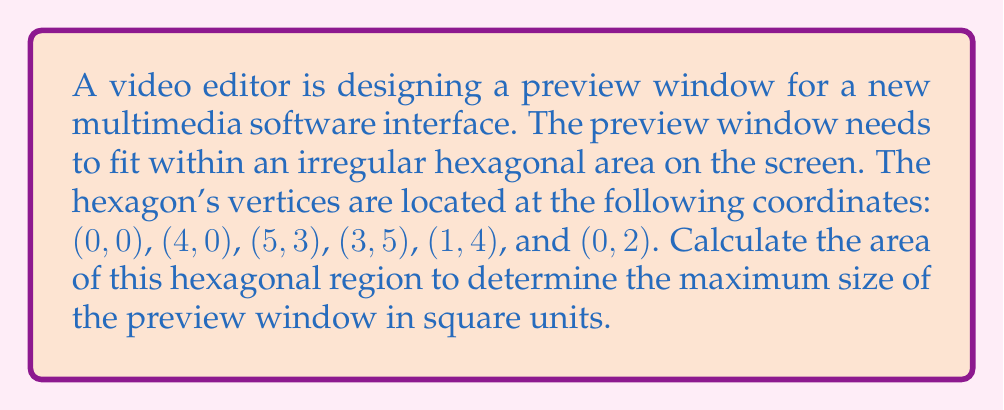Can you solve this math problem? To find the area of this irregular hexagon, we can use the Shoelace formula (also known as the surveyor's formula). The steps are as follows:

1) First, let's list the coordinates in order:
   $(x_1, y_1) = (0, 0)$
   $(x_2, y_2) = (4, 0)$
   $(x_3, y_3) = (5, 3)$
   $(x_4, y_4) = (3, 5)$
   $(x_5, y_5) = (1, 4)$
   $(x_6, y_6) = (0, 2)$

2) The Shoelace formula for a hexagon is:

   $$A = \frac{1}{2}|(x_1y_2 + x_2y_3 + x_3y_4 + x_4y_5 + x_5y_6 + x_6y_1) - (y_1x_2 + y_2x_3 + y_3x_4 + y_4x_5 + y_5x_6 + y_6x_1)|$$

3) Let's substitute the values:

   $$A = \frac{1}{2}|(0\cdot0 + 4\cdot3 + 5\cdot5 + 3\cdot4 + 1\cdot2 + 0\cdot0) - (0\cdot4 + 0\cdot5 + 3\cdot3 + 5\cdot1 + 4\cdot0 + 2\cdot0)|$$

4) Simplify:

   $$A = \frac{1}{2}|(0 + 12 + 25 + 12 + 2 + 0) - (0 + 0 + 9 + 5 + 0 + 0)|$$
   $$A = \frac{1}{2}|51 - 14|$$
   $$A = \frac{1}{2}(37)$$
   $$A = 18.5$$

Therefore, the area of the hexagonal region, which determines the maximum size of the preview window, is 18.5 square units.
Answer: 18.5 square units 